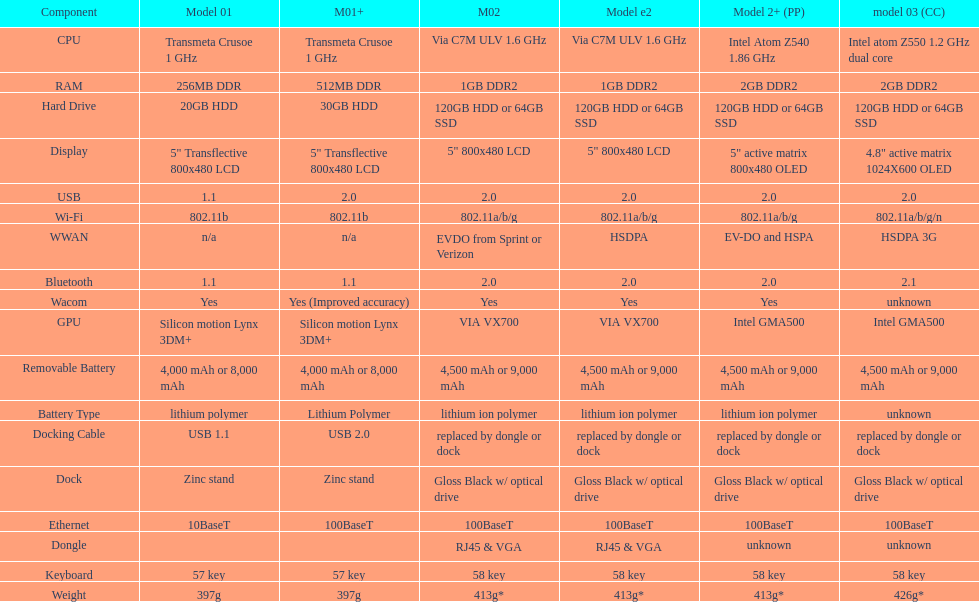What component comes after bluetooth? Wacom. 